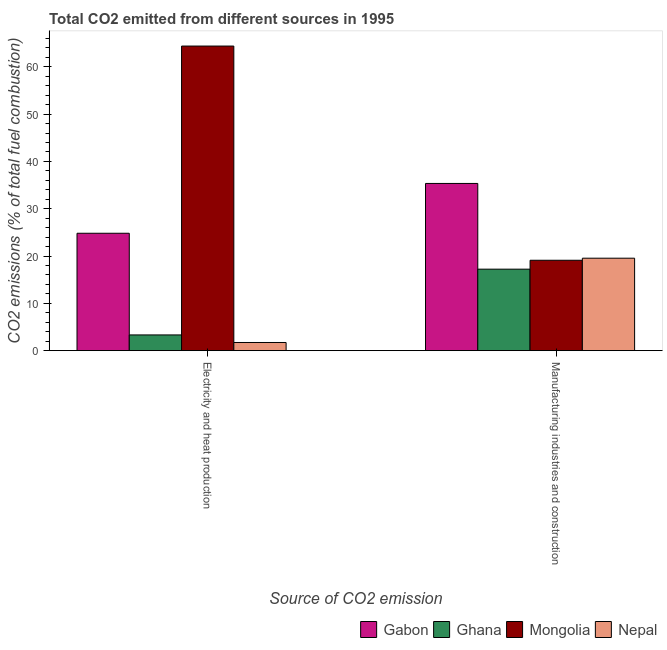How many groups of bars are there?
Your answer should be very brief. 2. Are the number of bars on each tick of the X-axis equal?
Your answer should be compact. Yes. How many bars are there on the 2nd tick from the left?
Ensure brevity in your answer.  4. What is the label of the 2nd group of bars from the left?
Ensure brevity in your answer.  Manufacturing industries and construction. What is the co2 emissions due to manufacturing industries in Mongolia?
Your answer should be compact. 19.1. Across all countries, what is the maximum co2 emissions due to manufacturing industries?
Keep it short and to the point. 35.34. Across all countries, what is the minimum co2 emissions due to electricity and heat production?
Your answer should be very brief. 1.72. In which country was the co2 emissions due to manufacturing industries maximum?
Make the answer very short. Gabon. What is the total co2 emissions due to electricity and heat production in the graph?
Your answer should be compact. 94.24. What is the difference between the co2 emissions due to manufacturing industries in Ghana and that in Gabon?
Keep it short and to the point. -18.12. What is the difference between the co2 emissions due to electricity and heat production in Gabon and the co2 emissions due to manufacturing industries in Mongolia?
Provide a short and direct response. 5.71. What is the average co2 emissions due to electricity and heat production per country?
Your response must be concise. 23.56. What is the difference between the co2 emissions due to electricity and heat production and co2 emissions due to manufacturing industries in Gabon?
Make the answer very short. -10.53. In how many countries, is the co2 emissions due to electricity and heat production greater than 40 %?
Your answer should be compact. 1. What is the ratio of the co2 emissions due to manufacturing industries in Nepal to that in Gabon?
Make the answer very short. 0.55. In how many countries, is the co2 emissions due to electricity and heat production greater than the average co2 emissions due to electricity and heat production taken over all countries?
Make the answer very short. 2. What does the 3rd bar from the left in Electricity and heat production represents?
Your answer should be very brief. Mongolia. What does the 2nd bar from the right in Electricity and heat production represents?
Offer a very short reply. Mongolia. How many bars are there?
Make the answer very short. 8. Are all the bars in the graph horizontal?
Your answer should be very brief. No. What is the difference between two consecutive major ticks on the Y-axis?
Ensure brevity in your answer.  10. Are the values on the major ticks of Y-axis written in scientific E-notation?
Give a very brief answer. No. Does the graph contain any zero values?
Ensure brevity in your answer.  No. Where does the legend appear in the graph?
Provide a succinct answer. Bottom right. How are the legend labels stacked?
Your answer should be very brief. Horizontal. What is the title of the graph?
Make the answer very short. Total CO2 emitted from different sources in 1995. What is the label or title of the X-axis?
Offer a terse response. Source of CO2 emission. What is the label or title of the Y-axis?
Your answer should be very brief. CO2 emissions (% of total fuel combustion). What is the CO2 emissions (% of total fuel combustion) in Gabon in Electricity and heat production?
Your answer should be compact. 24.81. What is the CO2 emissions (% of total fuel combustion) in Ghana in Electricity and heat production?
Ensure brevity in your answer.  3.32. What is the CO2 emissions (% of total fuel combustion) of Mongolia in Electricity and heat production?
Make the answer very short. 64.38. What is the CO2 emissions (% of total fuel combustion) of Nepal in Electricity and heat production?
Your response must be concise. 1.72. What is the CO2 emissions (% of total fuel combustion) in Gabon in Manufacturing industries and construction?
Keep it short and to the point. 35.34. What is the CO2 emissions (% of total fuel combustion) in Ghana in Manufacturing industries and construction?
Your answer should be compact. 17.22. What is the CO2 emissions (% of total fuel combustion) of Mongolia in Manufacturing industries and construction?
Your response must be concise. 19.1. What is the CO2 emissions (% of total fuel combustion) in Nepal in Manufacturing industries and construction?
Your answer should be very brief. 19.54. Across all Source of CO2 emission, what is the maximum CO2 emissions (% of total fuel combustion) in Gabon?
Offer a terse response. 35.34. Across all Source of CO2 emission, what is the maximum CO2 emissions (% of total fuel combustion) in Ghana?
Ensure brevity in your answer.  17.22. Across all Source of CO2 emission, what is the maximum CO2 emissions (% of total fuel combustion) in Mongolia?
Provide a short and direct response. 64.38. Across all Source of CO2 emission, what is the maximum CO2 emissions (% of total fuel combustion) of Nepal?
Offer a terse response. 19.54. Across all Source of CO2 emission, what is the minimum CO2 emissions (% of total fuel combustion) in Gabon?
Offer a terse response. 24.81. Across all Source of CO2 emission, what is the minimum CO2 emissions (% of total fuel combustion) in Ghana?
Make the answer very short. 3.32. Across all Source of CO2 emission, what is the minimum CO2 emissions (% of total fuel combustion) in Mongolia?
Make the answer very short. 19.1. Across all Source of CO2 emission, what is the minimum CO2 emissions (% of total fuel combustion) in Nepal?
Provide a short and direct response. 1.72. What is the total CO2 emissions (% of total fuel combustion) in Gabon in the graph?
Provide a short and direct response. 60.15. What is the total CO2 emissions (% of total fuel combustion) of Ghana in the graph?
Offer a terse response. 20.54. What is the total CO2 emissions (% of total fuel combustion) of Mongolia in the graph?
Your answer should be compact. 83.48. What is the total CO2 emissions (% of total fuel combustion) of Nepal in the graph?
Your answer should be very brief. 21.26. What is the difference between the CO2 emissions (% of total fuel combustion) of Gabon in Electricity and heat production and that in Manufacturing industries and construction?
Offer a very short reply. -10.53. What is the difference between the CO2 emissions (% of total fuel combustion) in Ghana in Electricity and heat production and that in Manufacturing industries and construction?
Ensure brevity in your answer.  -13.9. What is the difference between the CO2 emissions (% of total fuel combustion) of Mongolia in Electricity and heat production and that in Manufacturing industries and construction?
Offer a very short reply. 45.27. What is the difference between the CO2 emissions (% of total fuel combustion) in Nepal in Electricity and heat production and that in Manufacturing industries and construction?
Give a very brief answer. -17.82. What is the difference between the CO2 emissions (% of total fuel combustion) of Gabon in Electricity and heat production and the CO2 emissions (% of total fuel combustion) of Ghana in Manufacturing industries and construction?
Offer a terse response. 7.59. What is the difference between the CO2 emissions (% of total fuel combustion) in Gabon in Electricity and heat production and the CO2 emissions (% of total fuel combustion) in Mongolia in Manufacturing industries and construction?
Your answer should be very brief. 5.71. What is the difference between the CO2 emissions (% of total fuel combustion) in Gabon in Electricity and heat production and the CO2 emissions (% of total fuel combustion) in Nepal in Manufacturing industries and construction?
Give a very brief answer. 5.27. What is the difference between the CO2 emissions (% of total fuel combustion) of Ghana in Electricity and heat production and the CO2 emissions (% of total fuel combustion) of Mongolia in Manufacturing industries and construction?
Your response must be concise. -15.78. What is the difference between the CO2 emissions (% of total fuel combustion) in Ghana in Electricity and heat production and the CO2 emissions (% of total fuel combustion) in Nepal in Manufacturing industries and construction?
Ensure brevity in your answer.  -16.22. What is the difference between the CO2 emissions (% of total fuel combustion) in Mongolia in Electricity and heat production and the CO2 emissions (% of total fuel combustion) in Nepal in Manufacturing industries and construction?
Make the answer very short. 44.84. What is the average CO2 emissions (% of total fuel combustion) in Gabon per Source of CO2 emission?
Give a very brief answer. 30.08. What is the average CO2 emissions (% of total fuel combustion) of Ghana per Source of CO2 emission?
Offer a very short reply. 10.27. What is the average CO2 emissions (% of total fuel combustion) of Mongolia per Source of CO2 emission?
Provide a succinct answer. 41.74. What is the average CO2 emissions (% of total fuel combustion) of Nepal per Source of CO2 emission?
Offer a terse response. 10.63. What is the difference between the CO2 emissions (% of total fuel combustion) in Gabon and CO2 emissions (% of total fuel combustion) in Ghana in Electricity and heat production?
Offer a very short reply. 21.49. What is the difference between the CO2 emissions (% of total fuel combustion) of Gabon and CO2 emissions (% of total fuel combustion) of Mongolia in Electricity and heat production?
Your answer should be very brief. -39.57. What is the difference between the CO2 emissions (% of total fuel combustion) in Gabon and CO2 emissions (% of total fuel combustion) in Nepal in Electricity and heat production?
Ensure brevity in your answer.  23.09. What is the difference between the CO2 emissions (% of total fuel combustion) in Ghana and CO2 emissions (% of total fuel combustion) in Mongolia in Electricity and heat production?
Ensure brevity in your answer.  -61.05. What is the difference between the CO2 emissions (% of total fuel combustion) of Ghana and CO2 emissions (% of total fuel combustion) of Nepal in Electricity and heat production?
Make the answer very short. 1.6. What is the difference between the CO2 emissions (% of total fuel combustion) in Mongolia and CO2 emissions (% of total fuel combustion) in Nepal in Electricity and heat production?
Give a very brief answer. 62.65. What is the difference between the CO2 emissions (% of total fuel combustion) of Gabon and CO2 emissions (% of total fuel combustion) of Ghana in Manufacturing industries and construction?
Keep it short and to the point. 18.12. What is the difference between the CO2 emissions (% of total fuel combustion) of Gabon and CO2 emissions (% of total fuel combustion) of Mongolia in Manufacturing industries and construction?
Give a very brief answer. 16.23. What is the difference between the CO2 emissions (% of total fuel combustion) of Gabon and CO2 emissions (% of total fuel combustion) of Nepal in Manufacturing industries and construction?
Your answer should be very brief. 15.8. What is the difference between the CO2 emissions (% of total fuel combustion) of Ghana and CO2 emissions (% of total fuel combustion) of Mongolia in Manufacturing industries and construction?
Your response must be concise. -1.88. What is the difference between the CO2 emissions (% of total fuel combustion) in Ghana and CO2 emissions (% of total fuel combustion) in Nepal in Manufacturing industries and construction?
Your response must be concise. -2.32. What is the difference between the CO2 emissions (% of total fuel combustion) of Mongolia and CO2 emissions (% of total fuel combustion) of Nepal in Manufacturing industries and construction?
Provide a succinct answer. -0.44. What is the ratio of the CO2 emissions (% of total fuel combustion) in Gabon in Electricity and heat production to that in Manufacturing industries and construction?
Make the answer very short. 0.7. What is the ratio of the CO2 emissions (% of total fuel combustion) of Ghana in Electricity and heat production to that in Manufacturing industries and construction?
Provide a short and direct response. 0.19. What is the ratio of the CO2 emissions (% of total fuel combustion) in Mongolia in Electricity and heat production to that in Manufacturing industries and construction?
Make the answer very short. 3.37. What is the ratio of the CO2 emissions (% of total fuel combustion) of Nepal in Electricity and heat production to that in Manufacturing industries and construction?
Make the answer very short. 0.09. What is the difference between the highest and the second highest CO2 emissions (% of total fuel combustion) in Gabon?
Offer a very short reply. 10.53. What is the difference between the highest and the second highest CO2 emissions (% of total fuel combustion) in Ghana?
Provide a short and direct response. 13.9. What is the difference between the highest and the second highest CO2 emissions (% of total fuel combustion) in Mongolia?
Ensure brevity in your answer.  45.27. What is the difference between the highest and the second highest CO2 emissions (% of total fuel combustion) in Nepal?
Provide a short and direct response. 17.82. What is the difference between the highest and the lowest CO2 emissions (% of total fuel combustion) in Gabon?
Give a very brief answer. 10.53. What is the difference between the highest and the lowest CO2 emissions (% of total fuel combustion) in Ghana?
Ensure brevity in your answer.  13.9. What is the difference between the highest and the lowest CO2 emissions (% of total fuel combustion) in Mongolia?
Your answer should be compact. 45.27. What is the difference between the highest and the lowest CO2 emissions (% of total fuel combustion) in Nepal?
Ensure brevity in your answer.  17.82. 